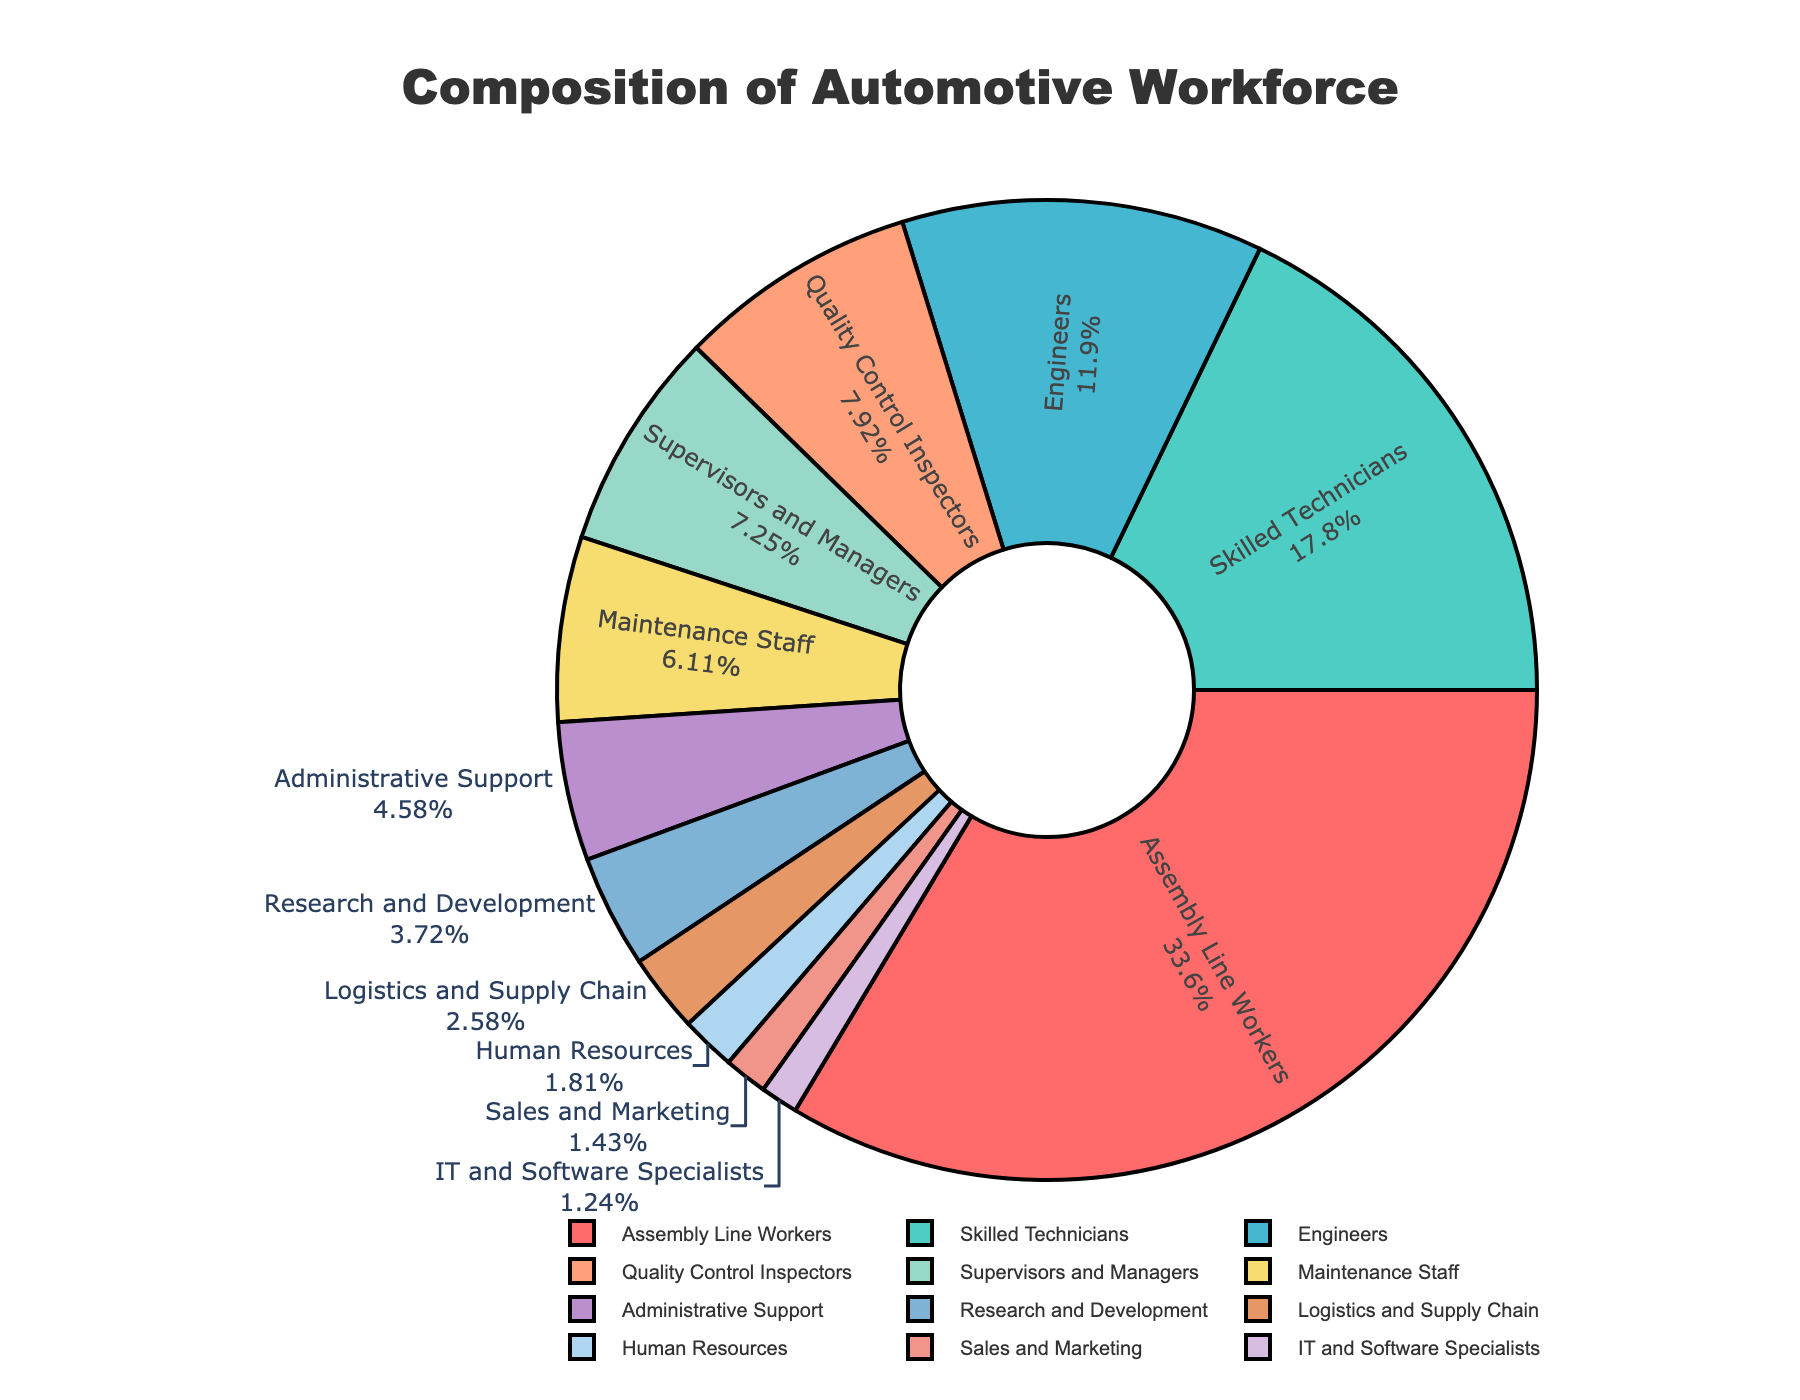What's the total percentage of the workforce that falls under the category of highly technical roles (Engineers, IT and Software Specialists, Research and Development)? We need to sum the percentages of Engineers (12.5%), IT and Software Specialists (1.3%), and Research and Development (3.9%). Adding them together, we get 12.5 + 1.3 + 3.9, which equals 17.7%
Answer: 17.7% How much larger is the percentage of Assembly Line Workers compared to Skilled Technicians? We subtract the percentage of Skilled Technicians (18.7%) from the percentage of Assembly Line Workers (35.2%). The difference is 35.2 - 18.7, which equals 16.5%
Answer: 16.5% Which job category has the smallest percentage? According to the data, IT and Software Specialists have the smallest percentage at 1.3%
Answer: IT and Software Specialists What is the combined percentage of Supervisors and Managers, and Quality Control Inspectors? We sum the percentages of Supervisors and Managers (7.6%) and Quality Control Inspectors (8.3%). Adding them together gives us 7.6 + 8.3, which equals 15.9%
Answer: 15.9% Which categories have a percentage greater than 10%? The categories with a percentage greater than 10% are Assembly Line Workers (35.2%), Skilled Technicians (18.7%), and Engineers (12.5%)
Answer: Assembly Line Workers, Skilled Technicians, Engineers Which job category appears in blue on the pie chart? Based on the color distribution given in the code and assuming a sequential order, the job category in blue should correspond to Engineers (because they are third in the list given red, green, then blue), visual confirmation might differ depending on the exact color representation
Answer: Engineers What is the difference in percentage between Maintenance Staff and Human Resources? We subtract the percentage of Human Resources (1.9%) from the percentage of Maintenance Staff (6.4%). The difference is 6.4 - 1.9, which equals 4.5%
Answer: 4.5% Is the percentage of Assembly Line Workers more than double that of Skilled Technicians? We compare twice the percentage of Skilled Technicians (18.7% * 2 = 37.4%) with the percentage of Assembly Line Workers (35.2%). Since 35.2% is not more than 37.4%, the answer is no
Answer: No What is the overall percentage of the workforce in administrative and support roles (Administrative Support, Human Resources)? We sum the percentages of Administrative Support (4.8%) and Human Resources (1.9%). Adding them together, we get 4.8 + 1.9, which equals 6.7%
Answer: 6.7% What is the average percentage of the three smallest job categories? The three smallest categories are IT and Software Specialists (1.3%), Sales and Marketing (1.5%), and Human Resources (1.9%). We sum these percentages and then divide by 3. The calculation is (1.3 + 1.5 + 1.9) / 3 = 4.7 / 3, which equals approximately 1.57%
Answer: 1.57% 